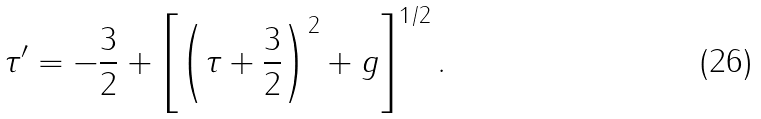Convert formula to latex. <formula><loc_0><loc_0><loc_500><loc_500>\tau ^ { \prime } = - \frac { 3 } { 2 } + \left [ \left ( \tau + \frac { 3 } { 2 } \right ) ^ { 2 } + g \right ] ^ { 1 / 2 } .</formula> 